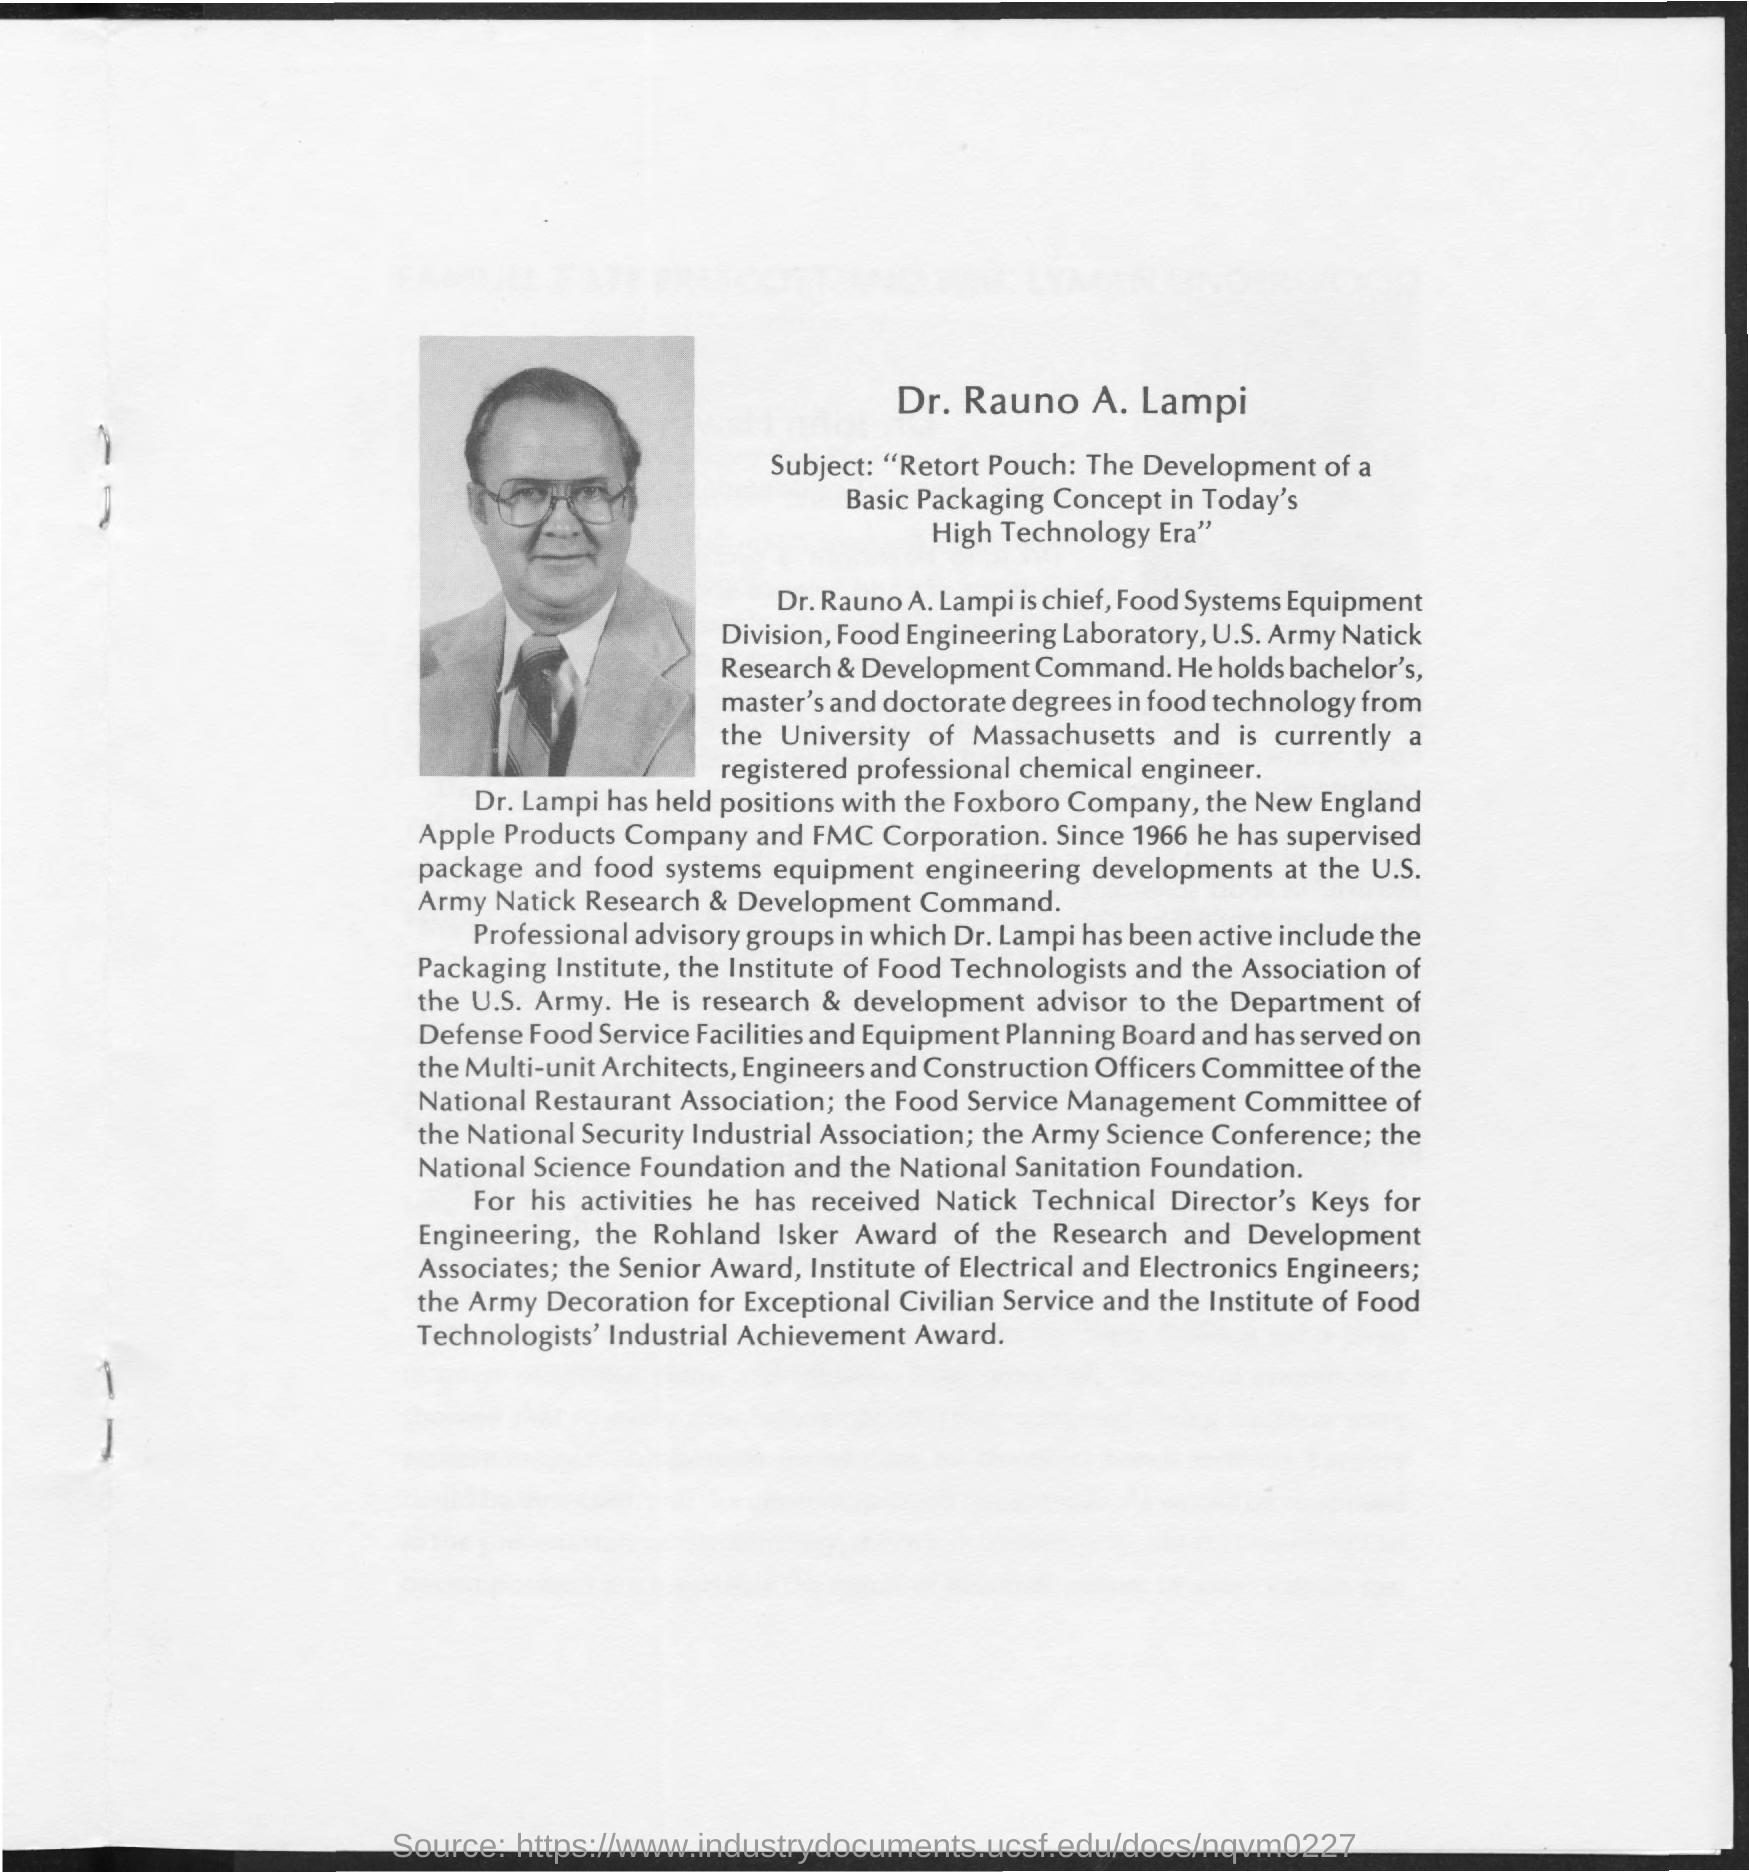Point out several critical features in this image. Dr. Rauno A. Lampi is the Chief of the Food Systems Equipment Division. 